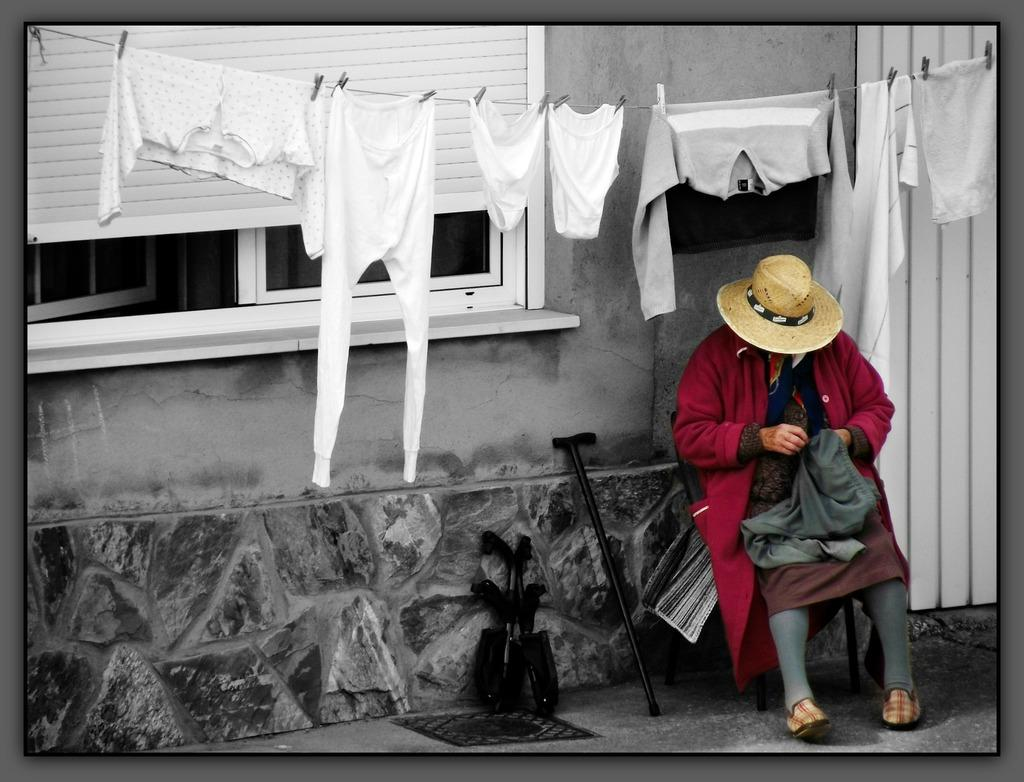What is the primary subject of the image? There is a person in the image. Can you describe the person's attire? The person is wearing clothes, a hat, and shoes. What is the person doing in the image? The person is sitting. What objects can be seen in the image besides the person? There is a hand stick, a footpath, a window, a rope, clothes, and a cloth clip in the image. What type of noise can be heard coming from the beetle in the image? There is no beetle present in the image, so it is not possible to determine what noise might be heard. --- Facts: 1. There is a car in the image. 2. The car is red. 3. The car has four wheels. 4. There is a road in the image. 5. The road is paved. 6. There are trees in the background of the image. 7. The sky is visible in the image. Absurd Topics: dance, rainbow, thought Conversation: What is the main subject of the image? There is a car in the image. Can you describe the car's color and features? The car is red and has four wheels. What is the setting of the image? There is a road in the image, and it is paved. What can be seen in the background of the image? There are trees and the sky visible in the background. Reasoning: Let's think step by step in order to produce the conversation. We start by identifying the main subject of the image, which is the car. Then, we describe the car's color and features. Next, we mention the setting of the image, which includes the road. Finally, we describe the background of the image, which includes trees and the sky. Absurd Question/Answer: What type of dance is the car performing in the image? Cars do not perform dances, so this question is not applicable to the image. --- Facts: 1. There is a dog in the image. 2. The dog is brown. 3. The dog is sitting. 4. There is a bowl in the image. 5. The bowl is empty. 6. There is a fence in the image. 7. The fence is made of wood. 8. There is a grassy area in the image. Absurd Topics: ocean, guitar, idea Conversation: What is the main subject of the image? There is a dog in the image. Can you describe the dog's appearance? The dog is brown and is sitting. What objects can be seen in the image besides the dog? There is a bowl, a fence, and a grassy area in the image. What is the condition of the bowl in the image? The bowl 